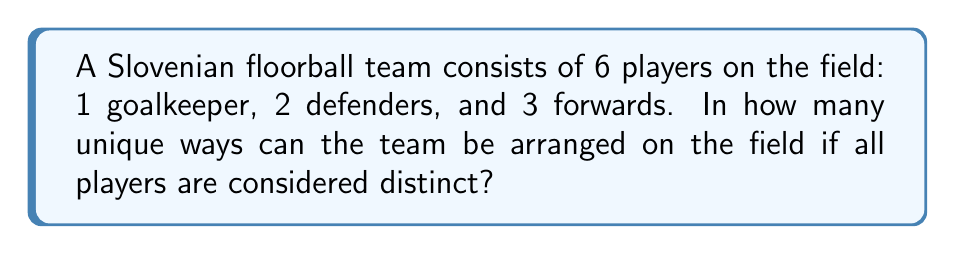Could you help me with this problem? Let's approach this problem using permutation groups:

1) First, we need to understand that this is a permutation problem. We are arranging 6 distinct players in 6 distinct positions.

2) However, this is not a simple 6! permutation because the positions are restricted. We can break this down into three steps:

   a) Choosing the goalkeeper: There is only 1 way to do this, as there is only 1 goalkeeper position.
   
   b) Arranging the defenders: After the goalkeeper is placed, we have 5 players left, from which we need to choose 2 for the defender positions. This can be done in $\binom{5}{2}$ ways. Once chosen, these 2 can be arranged in 2! ways.
   
   c) Arranging the forwards: The remaining 3 players will be forwards, and they can be arranged in 3! ways.

3) Using the multiplication principle, the total number of arrangements is:

   $$ 1 \times \binom{5}{2} \times 2! \times 3! $$

4) Let's calculate this step by step:
   
   $\binom{5}{2} = \frac{5!}{2!(5-2)!} = \frac{5 \times 4}{2 \times 1} = 10$
   
   $$ 1 \times 10 \times 2 \times 6 = 120 $$

Therefore, there are 120 unique ways to arrange the team on the field.
Answer: 120 unique arrangements 